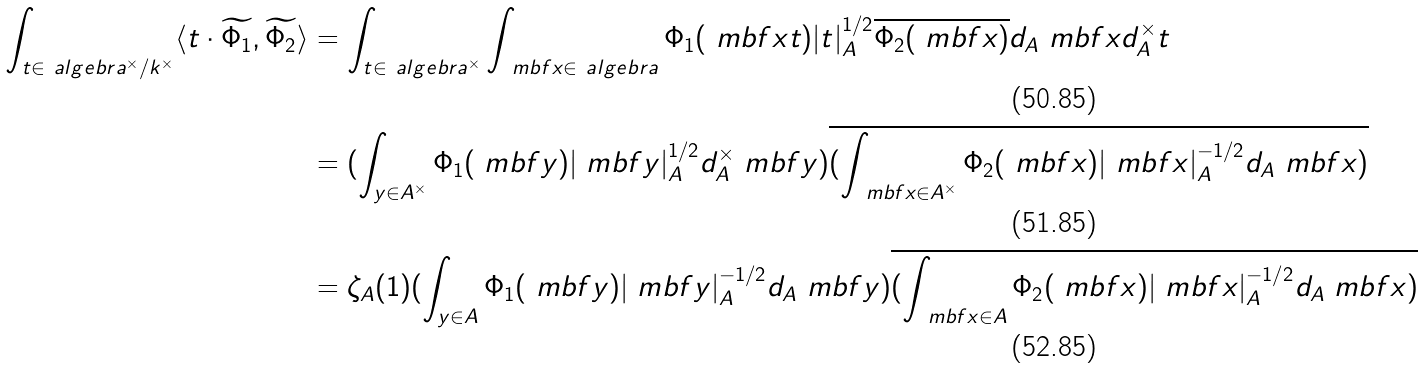Convert formula to latex. <formula><loc_0><loc_0><loc_500><loc_500>\int _ { t \in \ a l g e b r a ^ { \times } / k ^ { \times } } \langle t \cdot \widetilde { \Phi _ { 1 } } , \widetilde { \Phi _ { 2 } } \rangle & = \int _ { t \in \ a l g e b r a ^ { \times } } \int _ { \ m b f x \in \ a l g e b r a } \Phi _ { 1 } ( \ m b f x t ) | t | _ { A } ^ { 1 / 2 } \overline { \Phi _ { 2 } ( \ m b f x ) } d _ { A } \ m b f x d _ { A } ^ { \times } t \\ & = ( \int _ { y \in A ^ { \times } } \Phi _ { 1 } ( \ m b f y ) | \ m b f y | _ { A } ^ { 1 / 2 } d ^ { \times } _ { A } \ m b f y ) \overline { ( \int _ { \ m b f x \in A ^ { \times } } \Phi _ { 2 } ( \ m b f x ) | \ m b f x | _ { A } ^ { - 1 / 2 } d _ { A } \ m b f x ) } \\ & = \zeta _ { A } ( 1 ) ( \int _ { y \in A } \Phi _ { 1 } ( \ m b f y ) | \ m b f y | _ { A } ^ { - 1 / 2 } d _ { A } \ m b f y ) \overline { ( \int _ { \ m b f x \in A } \Phi _ { 2 } ( \ m b f x ) | \ m b f x | _ { A } ^ { - 1 / 2 } d _ { A } \ m b f x ) }</formula> 